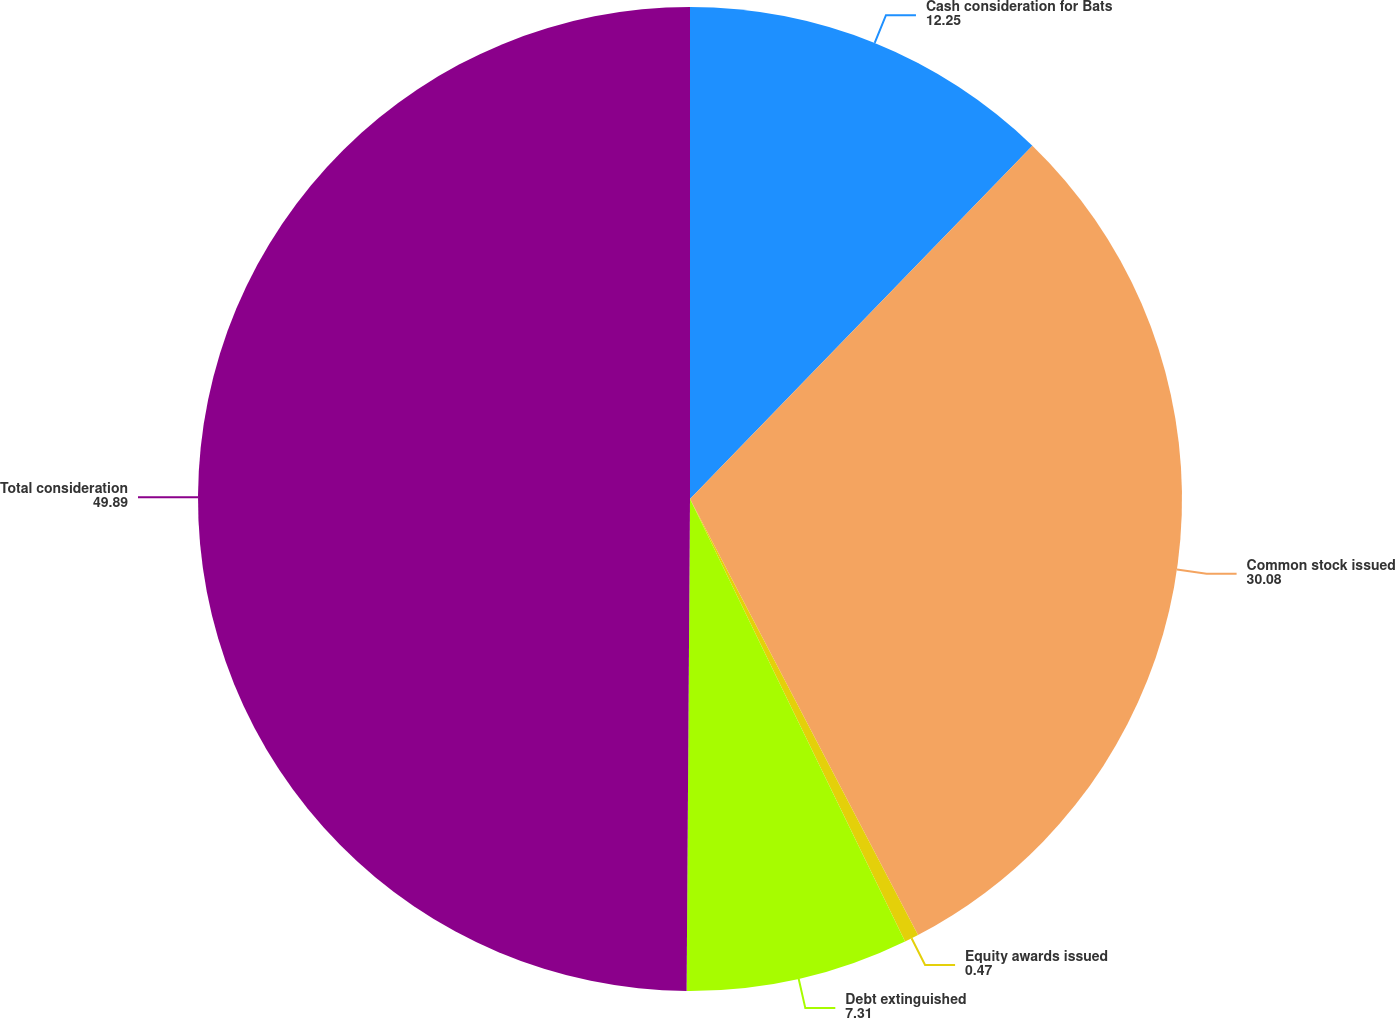<chart> <loc_0><loc_0><loc_500><loc_500><pie_chart><fcel>Cash consideration for Bats<fcel>Common stock issued<fcel>Equity awards issued<fcel>Debt extinguished<fcel>Total consideration<nl><fcel>12.25%<fcel>30.08%<fcel>0.47%<fcel>7.31%<fcel>49.89%<nl></chart> 